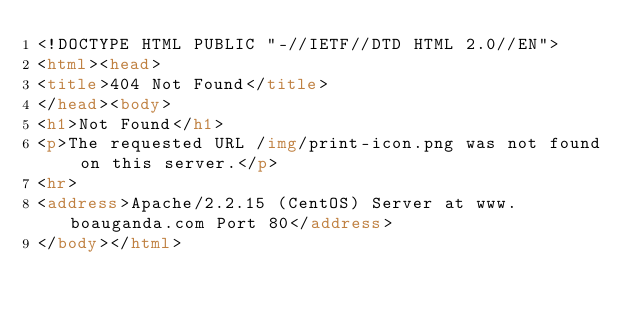Convert code to text. <code><loc_0><loc_0><loc_500><loc_500><_HTML_><!DOCTYPE HTML PUBLIC "-//IETF//DTD HTML 2.0//EN">
<html><head>
<title>404 Not Found</title>
</head><body>
<h1>Not Found</h1>
<p>The requested URL /img/print-icon.png was not found on this server.</p>
<hr>
<address>Apache/2.2.15 (CentOS) Server at www.boauganda.com Port 80</address>
</body></html>
</code> 